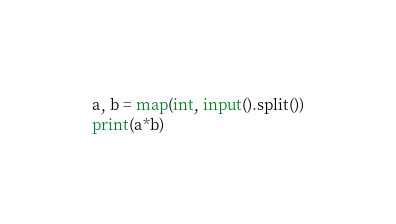Convert code to text. <code><loc_0><loc_0><loc_500><loc_500><_Python_>a, b = map(int, input().split())
print(a*b)</code> 